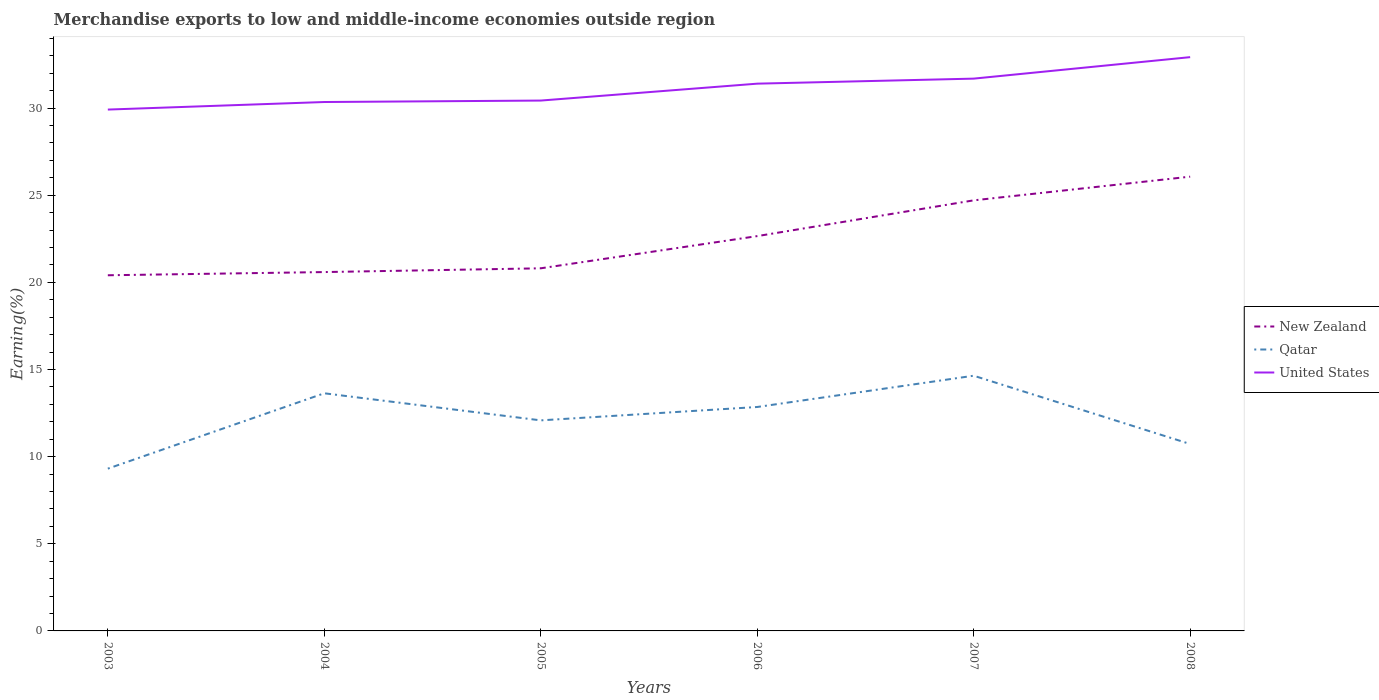How many different coloured lines are there?
Give a very brief answer. 3. Is the number of lines equal to the number of legend labels?
Ensure brevity in your answer.  Yes. Across all years, what is the maximum percentage of amount earned from merchandise exports in New Zealand?
Offer a very short reply. 20.41. In which year was the percentage of amount earned from merchandise exports in Qatar maximum?
Offer a terse response. 2003. What is the total percentage of amount earned from merchandise exports in Qatar in the graph?
Ensure brevity in your answer.  -2.77. What is the difference between the highest and the second highest percentage of amount earned from merchandise exports in Qatar?
Your response must be concise. 5.33. Is the percentage of amount earned from merchandise exports in New Zealand strictly greater than the percentage of amount earned from merchandise exports in United States over the years?
Offer a terse response. Yes. How many years are there in the graph?
Ensure brevity in your answer.  6. Are the values on the major ticks of Y-axis written in scientific E-notation?
Give a very brief answer. No. Does the graph contain any zero values?
Your answer should be compact. No. Does the graph contain grids?
Keep it short and to the point. No. Where does the legend appear in the graph?
Give a very brief answer. Center right. How many legend labels are there?
Provide a succinct answer. 3. How are the legend labels stacked?
Keep it short and to the point. Vertical. What is the title of the graph?
Your answer should be compact. Merchandise exports to low and middle-income economies outside region. Does "Algeria" appear as one of the legend labels in the graph?
Offer a very short reply. No. What is the label or title of the Y-axis?
Your answer should be compact. Earning(%). What is the Earning(%) of New Zealand in 2003?
Your answer should be compact. 20.41. What is the Earning(%) in Qatar in 2003?
Provide a short and direct response. 9.31. What is the Earning(%) of United States in 2003?
Provide a succinct answer. 29.91. What is the Earning(%) of New Zealand in 2004?
Give a very brief answer. 20.59. What is the Earning(%) in Qatar in 2004?
Your answer should be very brief. 13.63. What is the Earning(%) of United States in 2004?
Make the answer very short. 30.35. What is the Earning(%) of New Zealand in 2005?
Your response must be concise. 20.8. What is the Earning(%) in Qatar in 2005?
Provide a short and direct response. 12.08. What is the Earning(%) of United States in 2005?
Provide a succinct answer. 30.43. What is the Earning(%) of New Zealand in 2006?
Make the answer very short. 22.65. What is the Earning(%) in Qatar in 2006?
Offer a very short reply. 12.85. What is the Earning(%) in United States in 2006?
Offer a very short reply. 31.4. What is the Earning(%) of New Zealand in 2007?
Provide a succinct answer. 24.7. What is the Earning(%) in Qatar in 2007?
Your answer should be compact. 14.64. What is the Earning(%) of United States in 2007?
Your response must be concise. 31.69. What is the Earning(%) of New Zealand in 2008?
Your answer should be very brief. 26.06. What is the Earning(%) of Qatar in 2008?
Your response must be concise. 10.72. What is the Earning(%) in United States in 2008?
Ensure brevity in your answer.  32.92. Across all years, what is the maximum Earning(%) of New Zealand?
Your response must be concise. 26.06. Across all years, what is the maximum Earning(%) of Qatar?
Give a very brief answer. 14.64. Across all years, what is the maximum Earning(%) in United States?
Offer a terse response. 32.92. Across all years, what is the minimum Earning(%) in New Zealand?
Offer a terse response. 20.41. Across all years, what is the minimum Earning(%) of Qatar?
Your answer should be very brief. 9.31. Across all years, what is the minimum Earning(%) in United States?
Offer a very short reply. 29.91. What is the total Earning(%) of New Zealand in the graph?
Your response must be concise. 135.22. What is the total Earning(%) in Qatar in the graph?
Make the answer very short. 73.24. What is the total Earning(%) in United States in the graph?
Keep it short and to the point. 186.69. What is the difference between the Earning(%) in New Zealand in 2003 and that in 2004?
Your answer should be very brief. -0.18. What is the difference between the Earning(%) in Qatar in 2003 and that in 2004?
Provide a succinct answer. -4.32. What is the difference between the Earning(%) in United States in 2003 and that in 2004?
Provide a short and direct response. -0.43. What is the difference between the Earning(%) of New Zealand in 2003 and that in 2005?
Make the answer very short. -0.4. What is the difference between the Earning(%) in Qatar in 2003 and that in 2005?
Provide a succinct answer. -2.77. What is the difference between the Earning(%) in United States in 2003 and that in 2005?
Your answer should be compact. -0.52. What is the difference between the Earning(%) in New Zealand in 2003 and that in 2006?
Give a very brief answer. -2.25. What is the difference between the Earning(%) in Qatar in 2003 and that in 2006?
Provide a succinct answer. -3.54. What is the difference between the Earning(%) of United States in 2003 and that in 2006?
Offer a very short reply. -1.49. What is the difference between the Earning(%) in New Zealand in 2003 and that in 2007?
Your answer should be very brief. -4.3. What is the difference between the Earning(%) of Qatar in 2003 and that in 2007?
Make the answer very short. -5.33. What is the difference between the Earning(%) in United States in 2003 and that in 2007?
Make the answer very short. -1.78. What is the difference between the Earning(%) of New Zealand in 2003 and that in 2008?
Provide a succinct answer. -5.66. What is the difference between the Earning(%) in Qatar in 2003 and that in 2008?
Give a very brief answer. -1.41. What is the difference between the Earning(%) in United States in 2003 and that in 2008?
Give a very brief answer. -3.01. What is the difference between the Earning(%) in New Zealand in 2004 and that in 2005?
Make the answer very short. -0.22. What is the difference between the Earning(%) of Qatar in 2004 and that in 2005?
Provide a short and direct response. 1.55. What is the difference between the Earning(%) in United States in 2004 and that in 2005?
Your answer should be very brief. -0.08. What is the difference between the Earning(%) in New Zealand in 2004 and that in 2006?
Make the answer very short. -2.06. What is the difference between the Earning(%) of Qatar in 2004 and that in 2006?
Your response must be concise. 0.79. What is the difference between the Earning(%) of United States in 2004 and that in 2006?
Ensure brevity in your answer.  -1.05. What is the difference between the Earning(%) in New Zealand in 2004 and that in 2007?
Keep it short and to the point. -4.11. What is the difference between the Earning(%) in Qatar in 2004 and that in 2007?
Offer a very short reply. -1.01. What is the difference between the Earning(%) of United States in 2004 and that in 2007?
Keep it short and to the point. -1.34. What is the difference between the Earning(%) in New Zealand in 2004 and that in 2008?
Your response must be concise. -5.47. What is the difference between the Earning(%) of Qatar in 2004 and that in 2008?
Make the answer very short. 2.91. What is the difference between the Earning(%) of United States in 2004 and that in 2008?
Ensure brevity in your answer.  -2.57. What is the difference between the Earning(%) of New Zealand in 2005 and that in 2006?
Your answer should be compact. -1.85. What is the difference between the Earning(%) in Qatar in 2005 and that in 2006?
Provide a succinct answer. -0.77. What is the difference between the Earning(%) in United States in 2005 and that in 2006?
Your answer should be very brief. -0.97. What is the difference between the Earning(%) of New Zealand in 2005 and that in 2007?
Provide a short and direct response. -3.9. What is the difference between the Earning(%) in Qatar in 2005 and that in 2007?
Your answer should be very brief. -2.56. What is the difference between the Earning(%) of United States in 2005 and that in 2007?
Ensure brevity in your answer.  -1.26. What is the difference between the Earning(%) of New Zealand in 2005 and that in 2008?
Offer a very short reply. -5.26. What is the difference between the Earning(%) in Qatar in 2005 and that in 2008?
Give a very brief answer. 1.36. What is the difference between the Earning(%) in United States in 2005 and that in 2008?
Provide a short and direct response. -2.49. What is the difference between the Earning(%) of New Zealand in 2006 and that in 2007?
Your response must be concise. -2.05. What is the difference between the Earning(%) of Qatar in 2006 and that in 2007?
Your answer should be very brief. -1.79. What is the difference between the Earning(%) in United States in 2006 and that in 2007?
Keep it short and to the point. -0.29. What is the difference between the Earning(%) of New Zealand in 2006 and that in 2008?
Give a very brief answer. -3.41. What is the difference between the Earning(%) in Qatar in 2006 and that in 2008?
Offer a terse response. 2.12. What is the difference between the Earning(%) of United States in 2006 and that in 2008?
Make the answer very short. -1.52. What is the difference between the Earning(%) of New Zealand in 2007 and that in 2008?
Give a very brief answer. -1.36. What is the difference between the Earning(%) of Qatar in 2007 and that in 2008?
Your answer should be compact. 3.92. What is the difference between the Earning(%) in United States in 2007 and that in 2008?
Offer a very short reply. -1.23. What is the difference between the Earning(%) of New Zealand in 2003 and the Earning(%) of Qatar in 2004?
Your answer should be very brief. 6.77. What is the difference between the Earning(%) of New Zealand in 2003 and the Earning(%) of United States in 2004?
Give a very brief answer. -9.94. What is the difference between the Earning(%) of Qatar in 2003 and the Earning(%) of United States in 2004?
Provide a succinct answer. -21.04. What is the difference between the Earning(%) in New Zealand in 2003 and the Earning(%) in Qatar in 2005?
Keep it short and to the point. 8.32. What is the difference between the Earning(%) in New Zealand in 2003 and the Earning(%) in United States in 2005?
Your answer should be compact. -10.02. What is the difference between the Earning(%) of Qatar in 2003 and the Earning(%) of United States in 2005?
Your answer should be compact. -21.12. What is the difference between the Earning(%) of New Zealand in 2003 and the Earning(%) of Qatar in 2006?
Offer a very short reply. 7.56. What is the difference between the Earning(%) of New Zealand in 2003 and the Earning(%) of United States in 2006?
Offer a terse response. -10.99. What is the difference between the Earning(%) in Qatar in 2003 and the Earning(%) in United States in 2006?
Give a very brief answer. -22.09. What is the difference between the Earning(%) of New Zealand in 2003 and the Earning(%) of Qatar in 2007?
Your answer should be very brief. 5.76. What is the difference between the Earning(%) of New Zealand in 2003 and the Earning(%) of United States in 2007?
Provide a succinct answer. -11.28. What is the difference between the Earning(%) of Qatar in 2003 and the Earning(%) of United States in 2007?
Make the answer very short. -22.38. What is the difference between the Earning(%) in New Zealand in 2003 and the Earning(%) in Qatar in 2008?
Ensure brevity in your answer.  9.68. What is the difference between the Earning(%) in New Zealand in 2003 and the Earning(%) in United States in 2008?
Give a very brief answer. -12.51. What is the difference between the Earning(%) of Qatar in 2003 and the Earning(%) of United States in 2008?
Your answer should be very brief. -23.61. What is the difference between the Earning(%) in New Zealand in 2004 and the Earning(%) in Qatar in 2005?
Make the answer very short. 8.51. What is the difference between the Earning(%) in New Zealand in 2004 and the Earning(%) in United States in 2005?
Offer a very short reply. -9.84. What is the difference between the Earning(%) in Qatar in 2004 and the Earning(%) in United States in 2005?
Your answer should be very brief. -16.79. What is the difference between the Earning(%) in New Zealand in 2004 and the Earning(%) in Qatar in 2006?
Ensure brevity in your answer.  7.74. What is the difference between the Earning(%) in New Zealand in 2004 and the Earning(%) in United States in 2006?
Provide a succinct answer. -10.81. What is the difference between the Earning(%) of Qatar in 2004 and the Earning(%) of United States in 2006?
Provide a short and direct response. -17.76. What is the difference between the Earning(%) of New Zealand in 2004 and the Earning(%) of Qatar in 2007?
Your answer should be very brief. 5.95. What is the difference between the Earning(%) of New Zealand in 2004 and the Earning(%) of United States in 2007?
Provide a short and direct response. -11.1. What is the difference between the Earning(%) of Qatar in 2004 and the Earning(%) of United States in 2007?
Make the answer very short. -18.05. What is the difference between the Earning(%) in New Zealand in 2004 and the Earning(%) in Qatar in 2008?
Your response must be concise. 9.87. What is the difference between the Earning(%) of New Zealand in 2004 and the Earning(%) of United States in 2008?
Keep it short and to the point. -12.33. What is the difference between the Earning(%) in Qatar in 2004 and the Earning(%) in United States in 2008?
Offer a very short reply. -19.29. What is the difference between the Earning(%) of New Zealand in 2005 and the Earning(%) of Qatar in 2006?
Offer a terse response. 7.96. What is the difference between the Earning(%) in New Zealand in 2005 and the Earning(%) in United States in 2006?
Ensure brevity in your answer.  -10.59. What is the difference between the Earning(%) of Qatar in 2005 and the Earning(%) of United States in 2006?
Your answer should be very brief. -19.32. What is the difference between the Earning(%) in New Zealand in 2005 and the Earning(%) in Qatar in 2007?
Your response must be concise. 6.16. What is the difference between the Earning(%) of New Zealand in 2005 and the Earning(%) of United States in 2007?
Offer a very short reply. -10.88. What is the difference between the Earning(%) of Qatar in 2005 and the Earning(%) of United States in 2007?
Keep it short and to the point. -19.61. What is the difference between the Earning(%) in New Zealand in 2005 and the Earning(%) in Qatar in 2008?
Make the answer very short. 10.08. What is the difference between the Earning(%) in New Zealand in 2005 and the Earning(%) in United States in 2008?
Provide a succinct answer. -12.11. What is the difference between the Earning(%) of Qatar in 2005 and the Earning(%) of United States in 2008?
Ensure brevity in your answer.  -20.84. What is the difference between the Earning(%) in New Zealand in 2006 and the Earning(%) in Qatar in 2007?
Offer a terse response. 8.01. What is the difference between the Earning(%) in New Zealand in 2006 and the Earning(%) in United States in 2007?
Give a very brief answer. -9.04. What is the difference between the Earning(%) in Qatar in 2006 and the Earning(%) in United States in 2007?
Provide a short and direct response. -18.84. What is the difference between the Earning(%) in New Zealand in 2006 and the Earning(%) in Qatar in 2008?
Your response must be concise. 11.93. What is the difference between the Earning(%) of New Zealand in 2006 and the Earning(%) of United States in 2008?
Ensure brevity in your answer.  -10.27. What is the difference between the Earning(%) of Qatar in 2006 and the Earning(%) of United States in 2008?
Your response must be concise. -20.07. What is the difference between the Earning(%) of New Zealand in 2007 and the Earning(%) of Qatar in 2008?
Give a very brief answer. 13.98. What is the difference between the Earning(%) in New Zealand in 2007 and the Earning(%) in United States in 2008?
Your response must be concise. -8.22. What is the difference between the Earning(%) of Qatar in 2007 and the Earning(%) of United States in 2008?
Give a very brief answer. -18.28. What is the average Earning(%) of New Zealand per year?
Ensure brevity in your answer.  22.54. What is the average Earning(%) in Qatar per year?
Your answer should be compact. 12.21. What is the average Earning(%) of United States per year?
Make the answer very short. 31.11. In the year 2003, what is the difference between the Earning(%) of New Zealand and Earning(%) of Qatar?
Your response must be concise. 11.1. In the year 2003, what is the difference between the Earning(%) of New Zealand and Earning(%) of United States?
Offer a very short reply. -9.51. In the year 2003, what is the difference between the Earning(%) in Qatar and Earning(%) in United States?
Provide a short and direct response. -20.6. In the year 2004, what is the difference between the Earning(%) of New Zealand and Earning(%) of Qatar?
Offer a very short reply. 6.95. In the year 2004, what is the difference between the Earning(%) of New Zealand and Earning(%) of United States?
Offer a very short reply. -9.76. In the year 2004, what is the difference between the Earning(%) in Qatar and Earning(%) in United States?
Offer a very short reply. -16.71. In the year 2005, what is the difference between the Earning(%) of New Zealand and Earning(%) of Qatar?
Provide a short and direct response. 8.72. In the year 2005, what is the difference between the Earning(%) in New Zealand and Earning(%) in United States?
Give a very brief answer. -9.62. In the year 2005, what is the difference between the Earning(%) in Qatar and Earning(%) in United States?
Offer a terse response. -18.35. In the year 2006, what is the difference between the Earning(%) in New Zealand and Earning(%) in Qatar?
Your answer should be compact. 9.8. In the year 2006, what is the difference between the Earning(%) in New Zealand and Earning(%) in United States?
Provide a succinct answer. -8.75. In the year 2006, what is the difference between the Earning(%) in Qatar and Earning(%) in United States?
Offer a very short reply. -18.55. In the year 2007, what is the difference between the Earning(%) in New Zealand and Earning(%) in Qatar?
Offer a terse response. 10.06. In the year 2007, what is the difference between the Earning(%) in New Zealand and Earning(%) in United States?
Provide a short and direct response. -6.98. In the year 2007, what is the difference between the Earning(%) of Qatar and Earning(%) of United States?
Keep it short and to the point. -17.05. In the year 2008, what is the difference between the Earning(%) of New Zealand and Earning(%) of Qatar?
Give a very brief answer. 15.34. In the year 2008, what is the difference between the Earning(%) of New Zealand and Earning(%) of United States?
Make the answer very short. -6.86. In the year 2008, what is the difference between the Earning(%) in Qatar and Earning(%) in United States?
Provide a short and direct response. -22.2. What is the ratio of the Earning(%) of Qatar in 2003 to that in 2004?
Make the answer very short. 0.68. What is the ratio of the Earning(%) of United States in 2003 to that in 2004?
Your response must be concise. 0.99. What is the ratio of the Earning(%) in New Zealand in 2003 to that in 2005?
Make the answer very short. 0.98. What is the ratio of the Earning(%) in Qatar in 2003 to that in 2005?
Provide a short and direct response. 0.77. What is the ratio of the Earning(%) in United States in 2003 to that in 2005?
Provide a succinct answer. 0.98. What is the ratio of the Earning(%) of New Zealand in 2003 to that in 2006?
Provide a short and direct response. 0.9. What is the ratio of the Earning(%) in Qatar in 2003 to that in 2006?
Offer a very short reply. 0.72. What is the ratio of the Earning(%) of United States in 2003 to that in 2006?
Your answer should be compact. 0.95. What is the ratio of the Earning(%) of New Zealand in 2003 to that in 2007?
Provide a short and direct response. 0.83. What is the ratio of the Earning(%) in Qatar in 2003 to that in 2007?
Make the answer very short. 0.64. What is the ratio of the Earning(%) of United States in 2003 to that in 2007?
Ensure brevity in your answer.  0.94. What is the ratio of the Earning(%) in New Zealand in 2003 to that in 2008?
Offer a terse response. 0.78. What is the ratio of the Earning(%) of Qatar in 2003 to that in 2008?
Offer a terse response. 0.87. What is the ratio of the Earning(%) of United States in 2003 to that in 2008?
Keep it short and to the point. 0.91. What is the ratio of the Earning(%) in Qatar in 2004 to that in 2005?
Offer a terse response. 1.13. What is the ratio of the Earning(%) in United States in 2004 to that in 2005?
Offer a very short reply. 1. What is the ratio of the Earning(%) in New Zealand in 2004 to that in 2006?
Keep it short and to the point. 0.91. What is the ratio of the Earning(%) of Qatar in 2004 to that in 2006?
Your answer should be compact. 1.06. What is the ratio of the Earning(%) in United States in 2004 to that in 2006?
Your answer should be compact. 0.97. What is the ratio of the Earning(%) of New Zealand in 2004 to that in 2007?
Offer a very short reply. 0.83. What is the ratio of the Earning(%) of Qatar in 2004 to that in 2007?
Your answer should be compact. 0.93. What is the ratio of the Earning(%) of United States in 2004 to that in 2007?
Your answer should be very brief. 0.96. What is the ratio of the Earning(%) in New Zealand in 2004 to that in 2008?
Your answer should be compact. 0.79. What is the ratio of the Earning(%) in Qatar in 2004 to that in 2008?
Your response must be concise. 1.27. What is the ratio of the Earning(%) of United States in 2004 to that in 2008?
Give a very brief answer. 0.92. What is the ratio of the Earning(%) in New Zealand in 2005 to that in 2006?
Make the answer very short. 0.92. What is the ratio of the Earning(%) in Qatar in 2005 to that in 2006?
Ensure brevity in your answer.  0.94. What is the ratio of the Earning(%) of United States in 2005 to that in 2006?
Your answer should be compact. 0.97. What is the ratio of the Earning(%) in New Zealand in 2005 to that in 2007?
Your answer should be compact. 0.84. What is the ratio of the Earning(%) of Qatar in 2005 to that in 2007?
Keep it short and to the point. 0.83. What is the ratio of the Earning(%) of United States in 2005 to that in 2007?
Your response must be concise. 0.96. What is the ratio of the Earning(%) in New Zealand in 2005 to that in 2008?
Give a very brief answer. 0.8. What is the ratio of the Earning(%) in Qatar in 2005 to that in 2008?
Provide a succinct answer. 1.13. What is the ratio of the Earning(%) of United States in 2005 to that in 2008?
Your answer should be very brief. 0.92. What is the ratio of the Earning(%) of New Zealand in 2006 to that in 2007?
Provide a succinct answer. 0.92. What is the ratio of the Earning(%) of Qatar in 2006 to that in 2007?
Your response must be concise. 0.88. What is the ratio of the Earning(%) of United States in 2006 to that in 2007?
Ensure brevity in your answer.  0.99. What is the ratio of the Earning(%) of New Zealand in 2006 to that in 2008?
Keep it short and to the point. 0.87. What is the ratio of the Earning(%) of Qatar in 2006 to that in 2008?
Give a very brief answer. 1.2. What is the ratio of the Earning(%) in United States in 2006 to that in 2008?
Your response must be concise. 0.95. What is the ratio of the Earning(%) in New Zealand in 2007 to that in 2008?
Give a very brief answer. 0.95. What is the ratio of the Earning(%) of Qatar in 2007 to that in 2008?
Offer a very short reply. 1.37. What is the ratio of the Earning(%) in United States in 2007 to that in 2008?
Your response must be concise. 0.96. What is the difference between the highest and the second highest Earning(%) of New Zealand?
Provide a short and direct response. 1.36. What is the difference between the highest and the second highest Earning(%) in Qatar?
Your answer should be very brief. 1.01. What is the difference between the highest and the second highest Earning(%) of United States?
Keep it short and to the point. 1.23. What is the difference between the highest and the lowest Earning(%) of New Zealand?
Offer a very short reply. 5.66. What is the difference between the highest and the lowest Earning(%) of Qatar?
Provide a succinct answer. 5.33. What is the difference between the highest and the lowest Earning(%) in United States?
Keep it short and to the point. 3.01. 